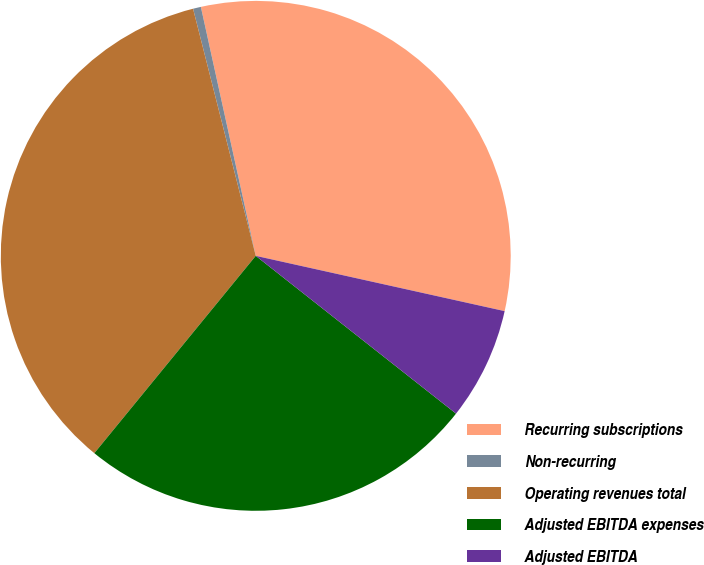<chart> <loc_0><loc_0><loc_500><loc_500><pie_chart><fcel>Recurring subscriptions<fcel>Non-recurring<fcel>Operating revenues total<fcel>Adjusted EBITDA expenses<fcel>Adjusted EBITDA<nl><fcel>31.93%<fcel>0.5%<fcel>35.13%<fcel>25.29%<fcel>7.14%<nl></chart> 